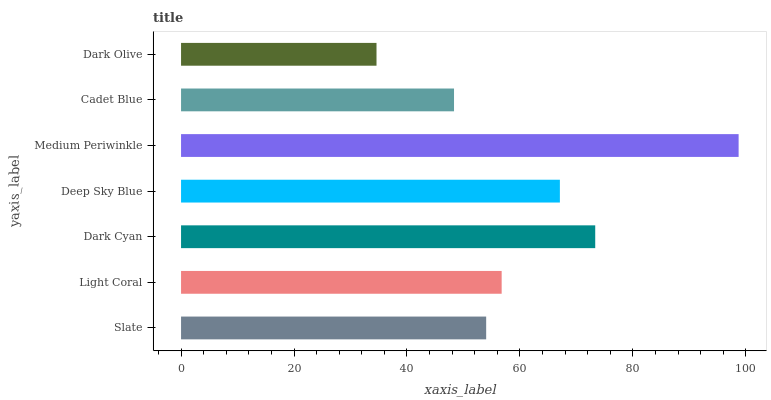Is Dark Olive the minimum?
Answer yes or no. Yes. Is Medium Periwinkle the maximum?
Answer yes or no. Yes. Is Light Coral the minimum?
Answer yes or no. No. Is Light Coral the maximum?
Answer yes or no. No. Is Light Coral greater than Slate?
Answer yes or no. Yes. Is Slate less than Light Coral?
Answer yes or no. Yes. Is Slate greater than Light Coral?
Answer yes or no. No. Is Light Coral less than Slate?
Answer yes or no. No. Is Light Coral the high median?
Answer yes or no. Yes. Is Light Coral the low median?
Answer yes or no. Yes. Is Dark Olive the high median?
Answer yes or no. No. Is Slate the low median?
Answer yes or no. No. 